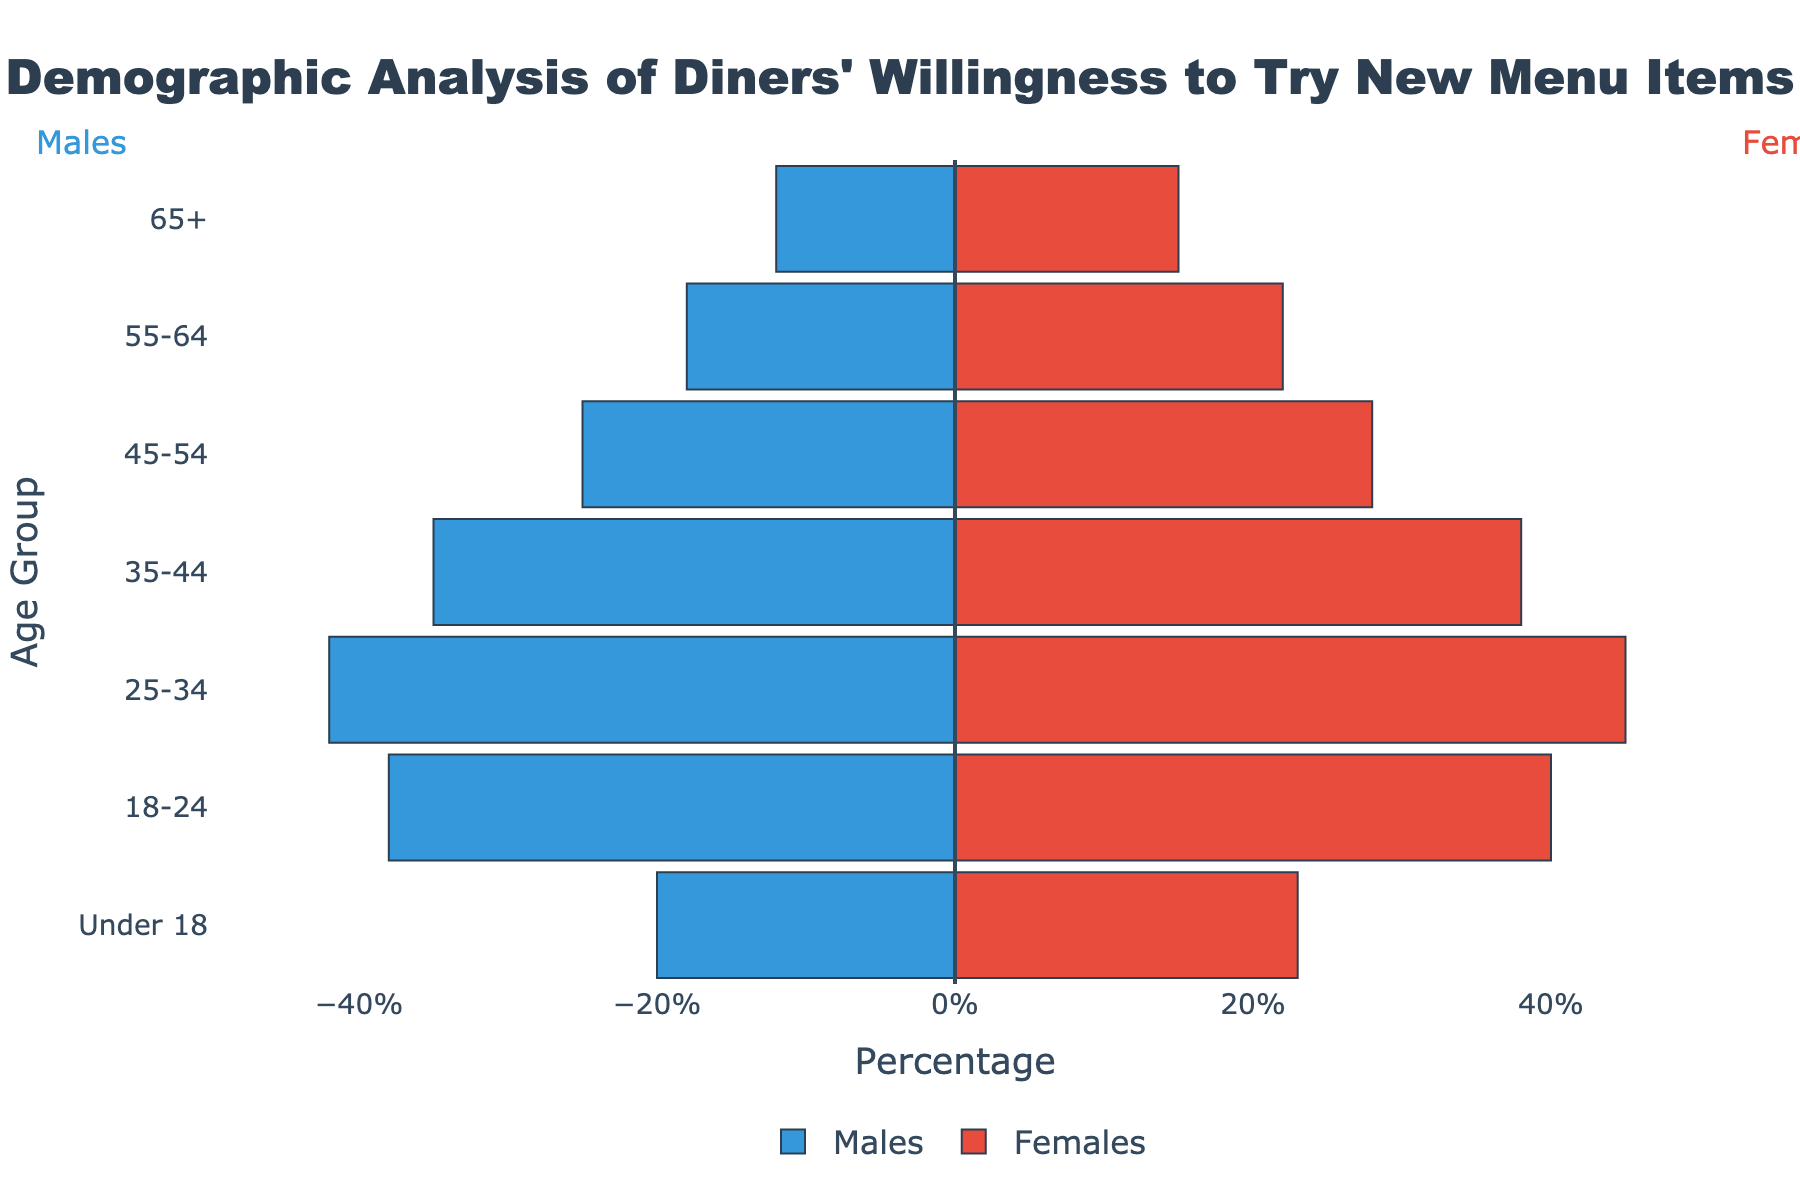what is the title of the plot? The title is displayed prominently at the top center of the plot.
Answer: "Demographic Analysis of Diners' Willingness to Try New Menu Items" which age group has the highest percentage of females willing to try new menu items? Examine the bars on the right side of the pyramid to determine the age group with the largest positive x-value for females.
Answer: 25-34 how many age groups are presented in the pyramid? Count the total number of unique age groups displayed on the y-axis in the figure.
Answer: 7 which gender from the 35-44 age group shows a higher percentage willingness to try new items? Compare the absolute values of the bars for males and females in the 35-44 age category on the plot.
Answer: Females what is the percentage of males willing to try new menu items in the 18-24 age group? Observe the bar corresponding to males in the 18-24 age group, noting the negative value.
Answer: 38% for the 55-64 age group, how does the percentage of females willing to try new menu items compare to males? Compare the lengths of the bars for both genders in the 55-64 age group by noting their absolute values.
Answer: Females have a higher willingness (22% vs 18%) which age group shows the smallest difference in willingness to try new menu items between genders? Calculate the difference between the absolute values of the bars for males and females in each age group, and identify the smallest difference.
Answer: 65+ what is the total percentage value for both genders combined in the 25-34 age group? Add the absolute values of percentages for males and females in the 25-34 age group.
Answer: 87% how many age groups have more than 20% of females willing to try new menu items? Count the number of age groups with the bar for females exceeding 20% on the x-axis.
Answer: 4 age groups (65+, 55-64, 25-34, Under 18) which gender demonstrates a greater overall willingness to try new menu items across all age groups? Sum the absolute values of bars for all age groups for both genders separately, and compare the totals.
Answer: Females 